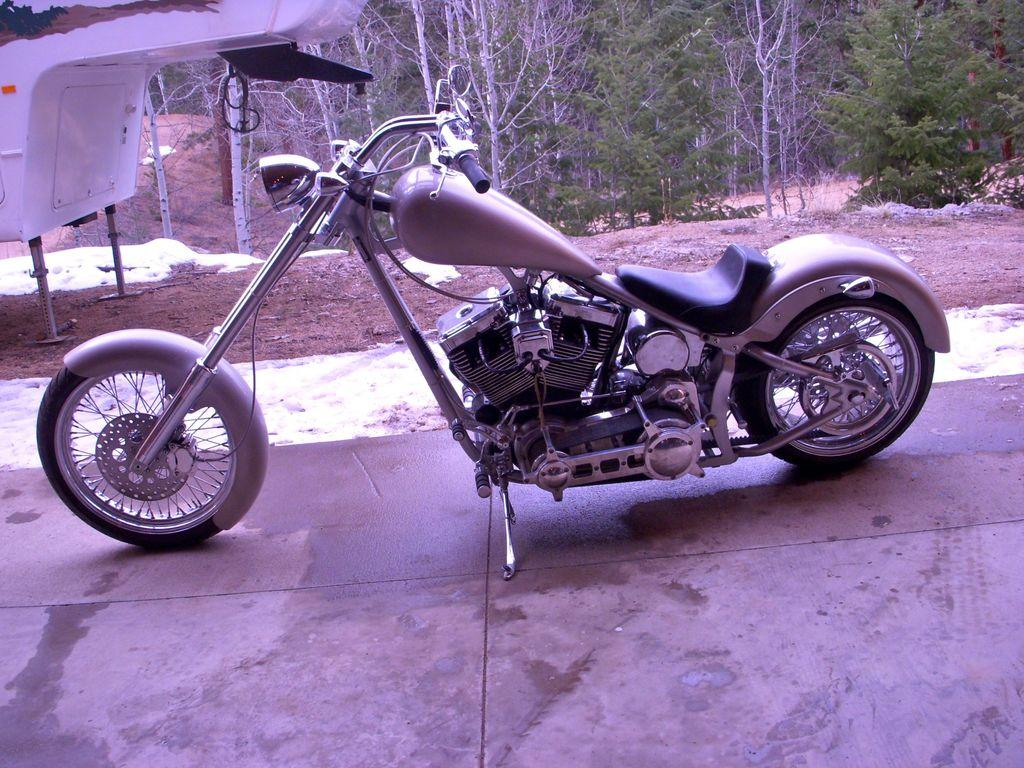What is the main subject of the image? There is a motorbike in the image. What is located on the ground in the image? There is an object on the ground in the image. What can be seen in the distance in the image? There are trees visible in the background of the image. What type of powder is being used to clean the motorbike in the image? There is no powder visible in the image, and no indication that the motorbike is being cleaned. 